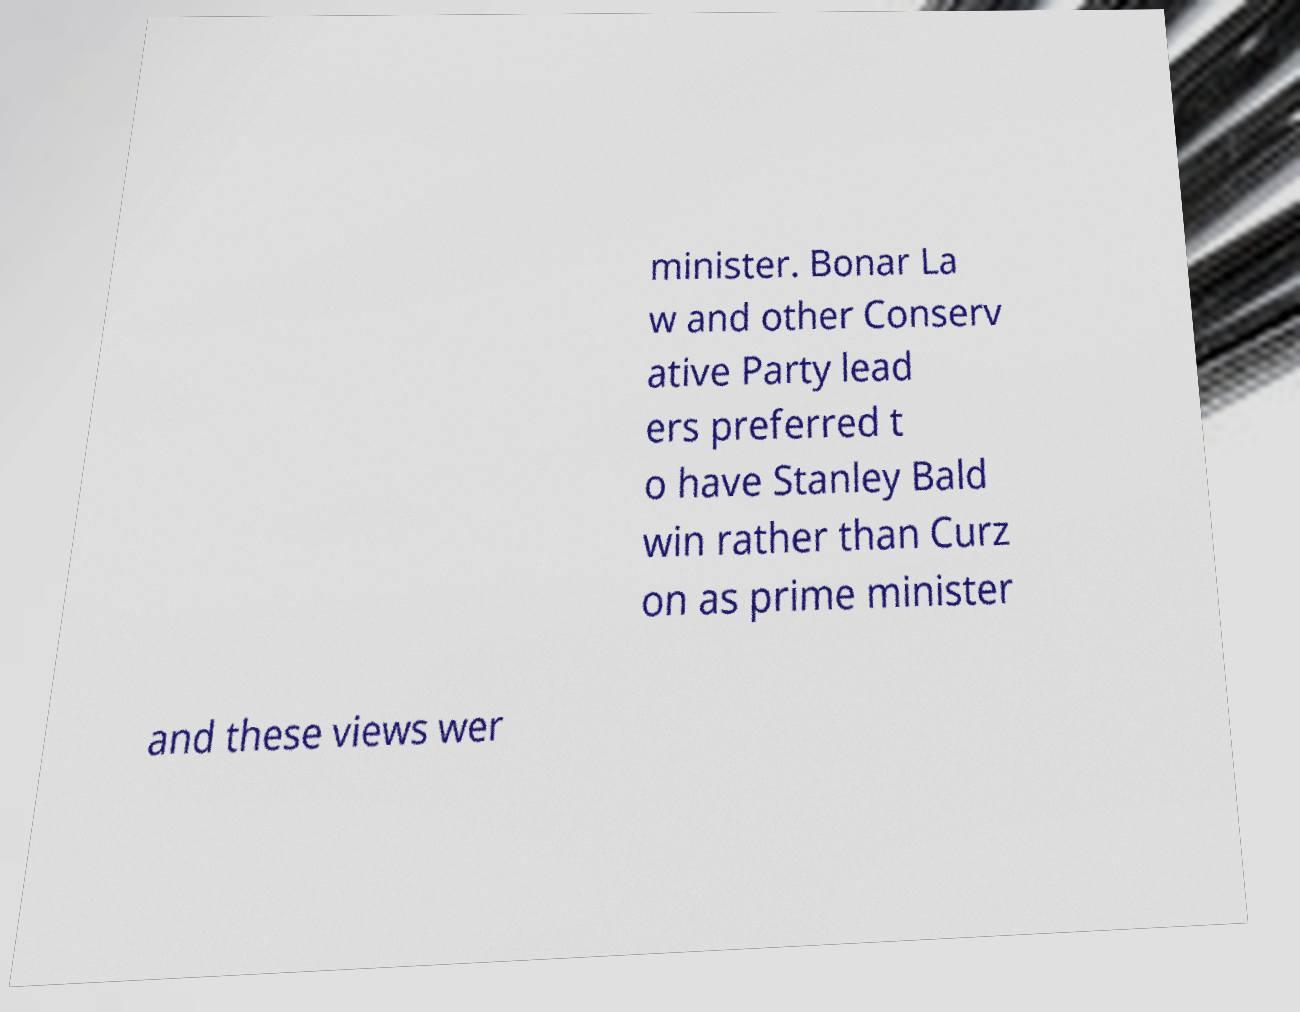Please identify and transcribe the text found in this image. minister. Bonar La w and other Conserv ative Party lead ers preferred t o have Stanley Bald win rather than Curz on as prime minister and these views wer 